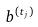Convert formula to latex. <formula><loc_0><loc_0><loc_500><loc_500>b ^ { ( t _ { j } ) }</formula> 